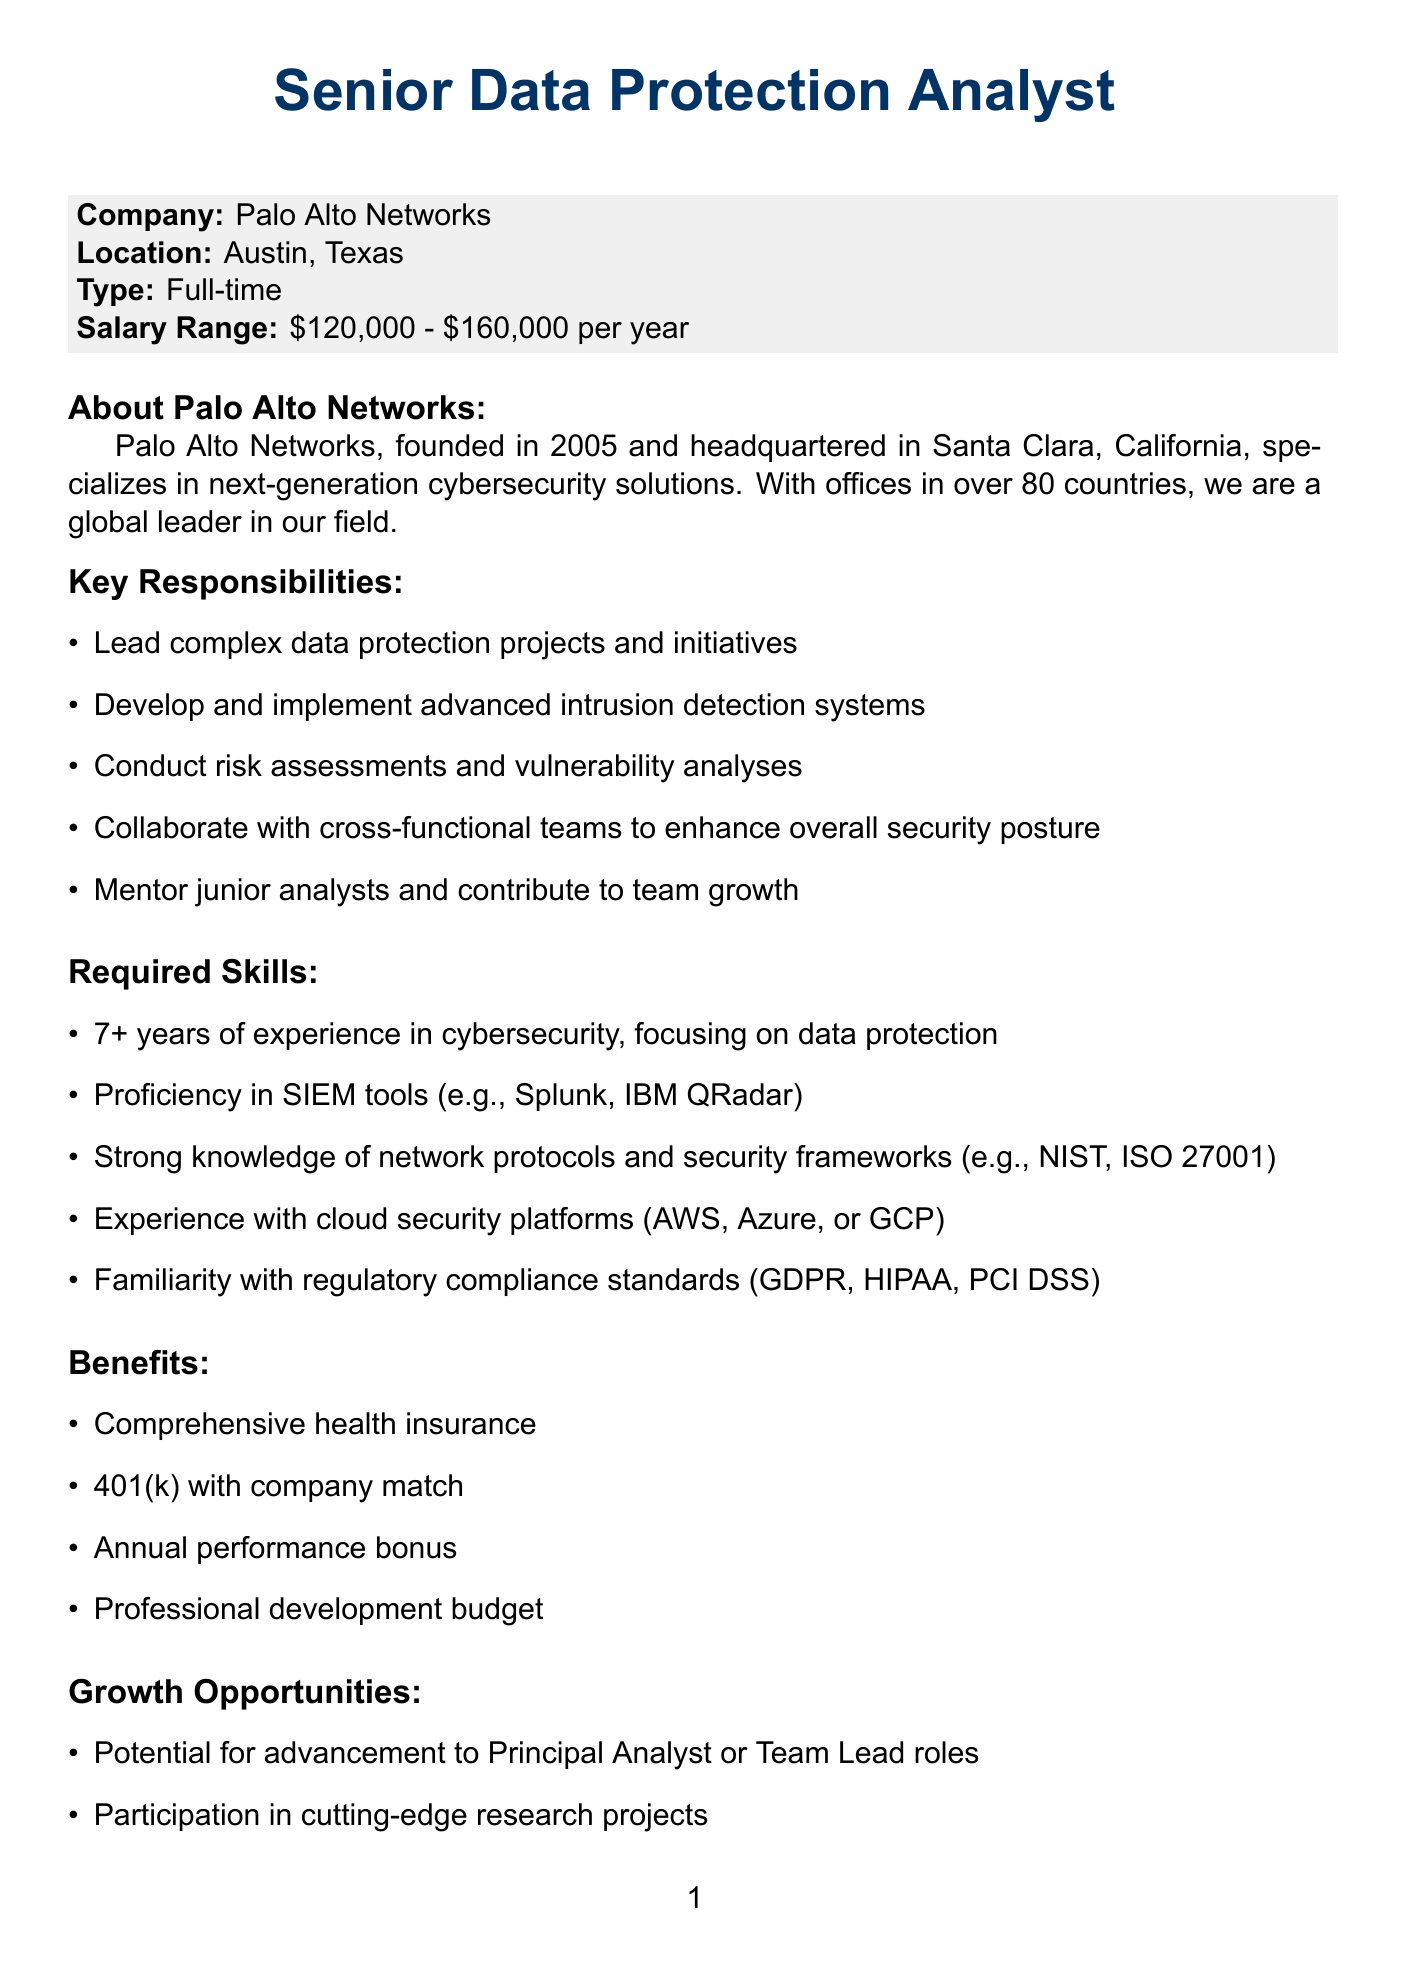What is the job title? The job title is stated clearly in the document as "Senior Data Protection Analyst."
Answer: Senior Data Protection Analyst Where is Palo Alto Networks headquartered? The headquarters location is mentioned in the company information section.
Answer: Santa Clara, California What is the salary range for the position? The salary range provides the expected compensation for the role, which is mentioned in the job details.
Answer: $120,000 - $160,000 per year Name one benefit offered for the position. Benefits are listed in a section of the document, and one example is asked for.
Answer: Comprehensive health insurance How many years of experience are required for the position? The required skills section specifies the experience needed for applicants.
Answer: 7+ years What type of projects will the analyst lead? This question draws from the responsibilities section, highlighting the focus of the role.
Answer: Complex data protection projects Who is the contact person for the job offer? The contact information section provides the name of the person to reach out to regarding the job.
Answer: Sarah Chen When is the application deadline? The application process section clearly specifies the date by which applications must be submitted.
Answer: June 30, 2023 What is one growth opportunity listed in the document? The growth opportunities section specifies options for career advancements or experiences available to the analyst.
Answer: Potential for advancement to Principal Analyst or Team Lead roles 